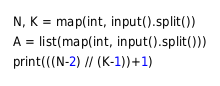Convert code to text. <code><loc_0><loc_0><loc_500><loc_500><_Python_>N, K = map(int, input().split())
A = list(map(int, input().split()))
print(((N-2) // (K-1))+1)
</code> 